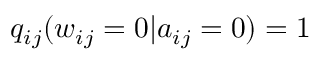Convert formula to latex. <formula><loc_0><loc_0><loc_500><loc_500>q _ { i j } ( w _ { i j } = 0 | a _ { i j } = 0 ) = 1</formula> 